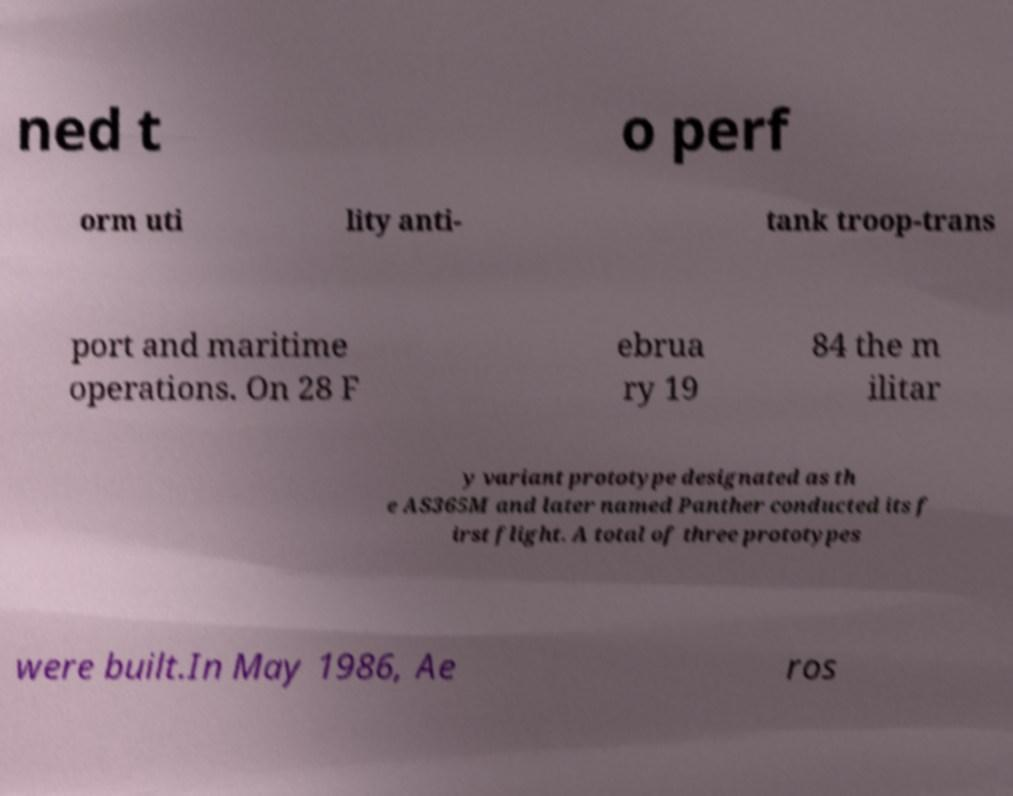What messages or text are displayed in this image? I need them in a readable, typed format. ned t o perf orm uti lity anti- tank troop-trans port and maritime operations. On 28 F ebrua ry 19 84 the m ilitar y variant prototype designated as th e AS365M and later named Panther conducted its f irst flight. A total of three prototypes were built.In May 1986, Ae ros 